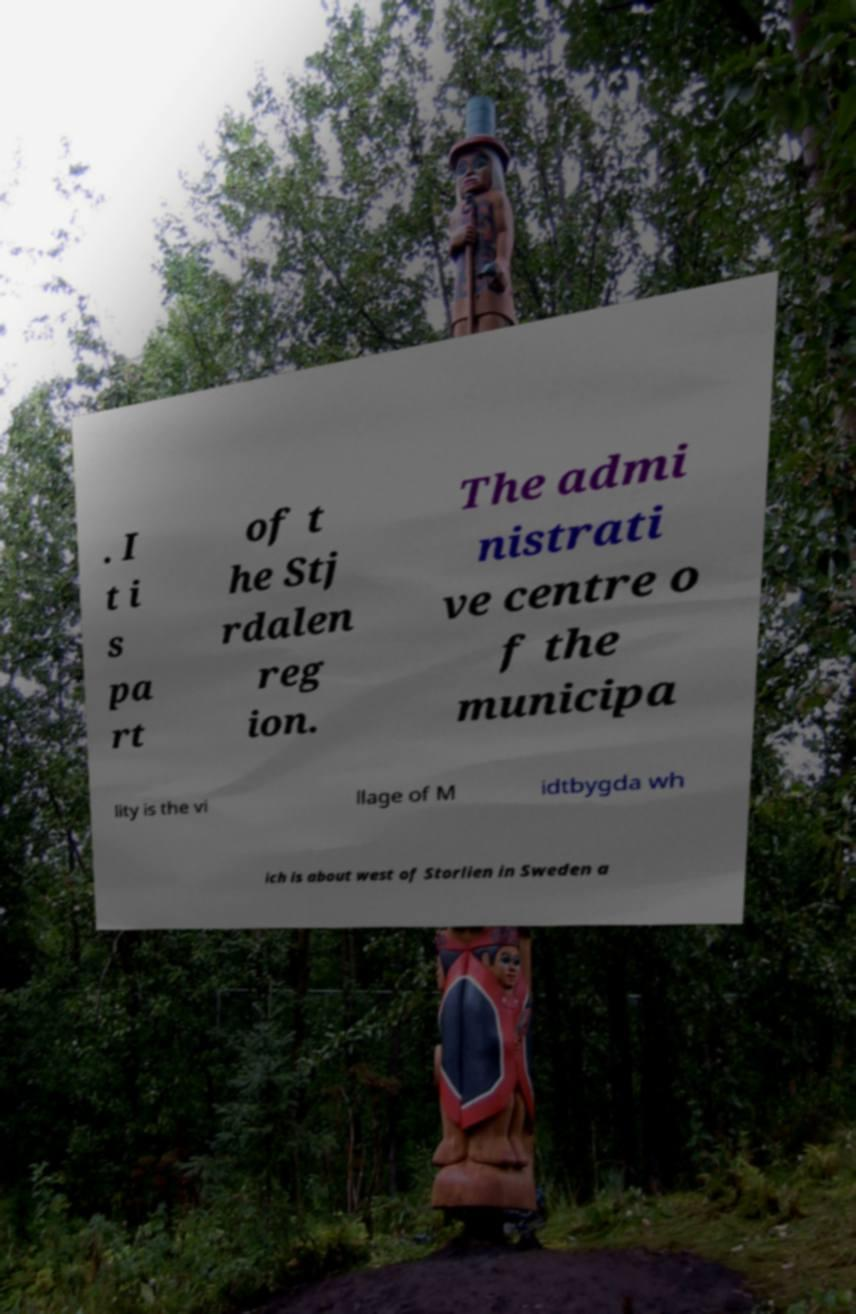Could you assist in decoding the text presented in this image and type it out clearly? . I t i s pa rt of t he Stj rdalen reg ion. The admi nistrati ve centre o f the municipa lity is the vi llage of M idtbygda wh ich is about west of Storlien in Sweden a 